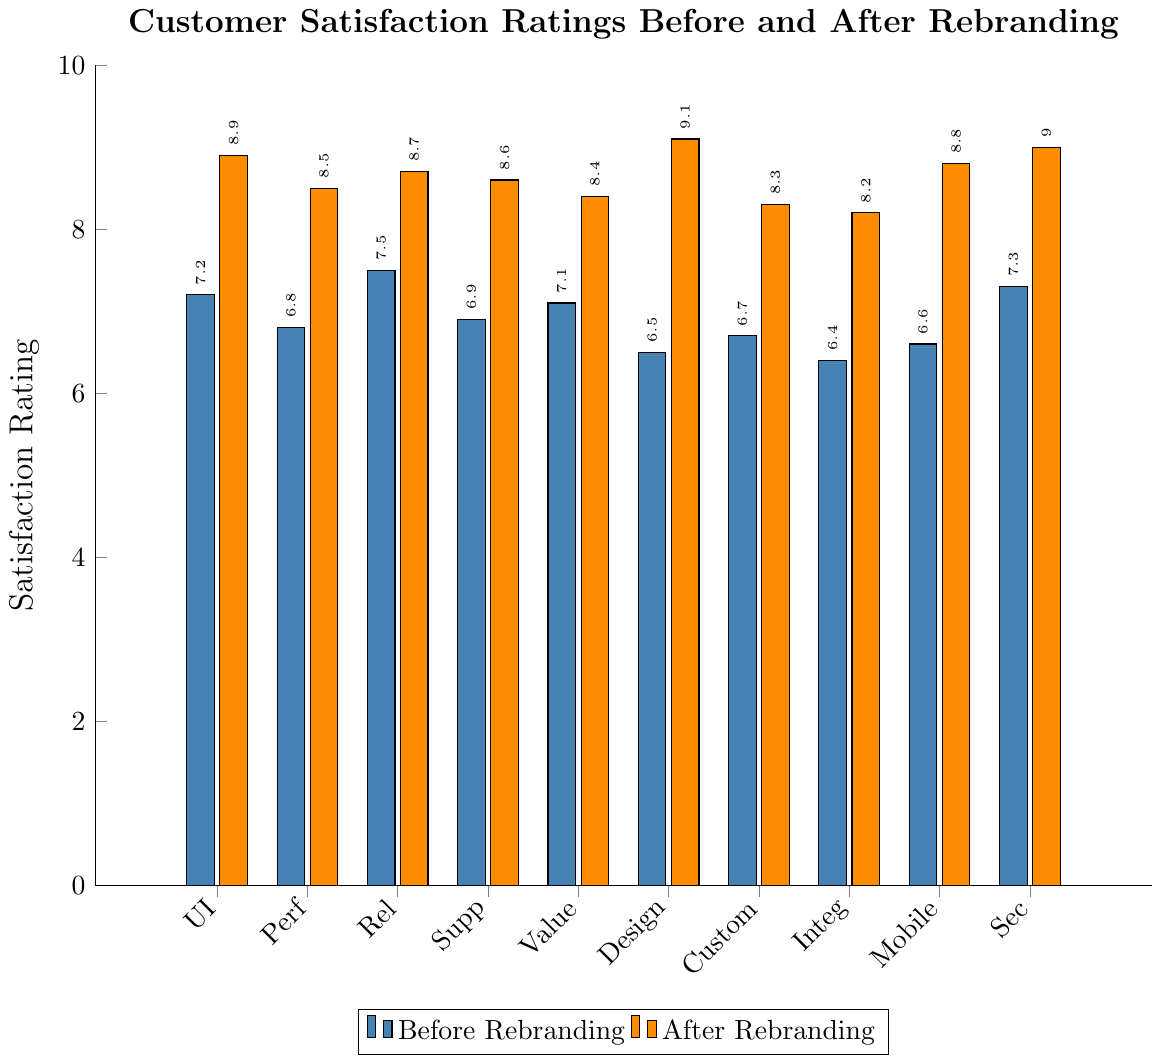What is the average satisfaction rating for the User Interface before and after the rebranding? To find the average satisfaction rating for the User Interface before and after the rebranding, add the ratings together and divide by 2: (7.2 + 8.9) / 2.
Answer: 8.05 Which feature experienced the highest increase in satisfaction rating after rebranding? To determine the feature with the highest increase, calculate the difference between the 'Before Rebranding' and 'After Rebranding' ratings for each feature. The feature with the largest difference is "Design".
Answer: Design How many features have a satisfaction rating of 8 or higher after rebranding? Count the features with 'After Rebranding' ratings that are 8 or higher. They are User Interface, Performance, Reliability, Customer Support, Value for Money, Design, Customization Options, Integration with Other Products, Mobile App, and Security Features. So, there are 10 features.
Answer: 10 Is the satisfaction rating for Design higher before or after rebranding? Compare the 'Before Rebranding' rating of 6.5 for Design with the 'After Rebranding' rating of 9.1.
Answer: After rebranding By how much did the satisfaction rating for Mobile App improve after rebranding? Subtract the 'Before Rebranding' rating of 6.6 for Mobile App from the 'After Rebranding' rating of 8.8: 8.8 - 6.6.
Answer: 2.2 Which features had a satisfaction rating below 7.0 before rebranding? Identify all features where 'Before Rebranding' ratings are below 7.0. They are Performance, Customer Support, Design, Customization Options, Integration with Other Products, and Mobile App.
Answer: 6 features What is the minimum satisfaction rating across all features after rebranding? Identify the lowest 'After Rebranding' rating across all features, which is 8.2 in Integration with Other Products.
Answer: 8.2 How much did the average satisfaction rating across all features improve after rebranding? First, calculate the average rating 'Before Rebranding' and 'After Rebranding': 
Before Rebranding = (7.2 + 6.8 + 7.5 + 6.9 + 7.1 + 6.5 + 6.7 + 6.4 + 6.6 + 7.3) / 10 = 6.90
After Rebranding = (8.9 + 8.5 + 8.7 + 8.6 + 8.4 + 9.1 + 8.3 + 8.2 + 8.8 + 9.0) / 10 = 8.65
Then, subtract the two averages: 8.65 - 6.90 = 1.75
Answer: 1.75 